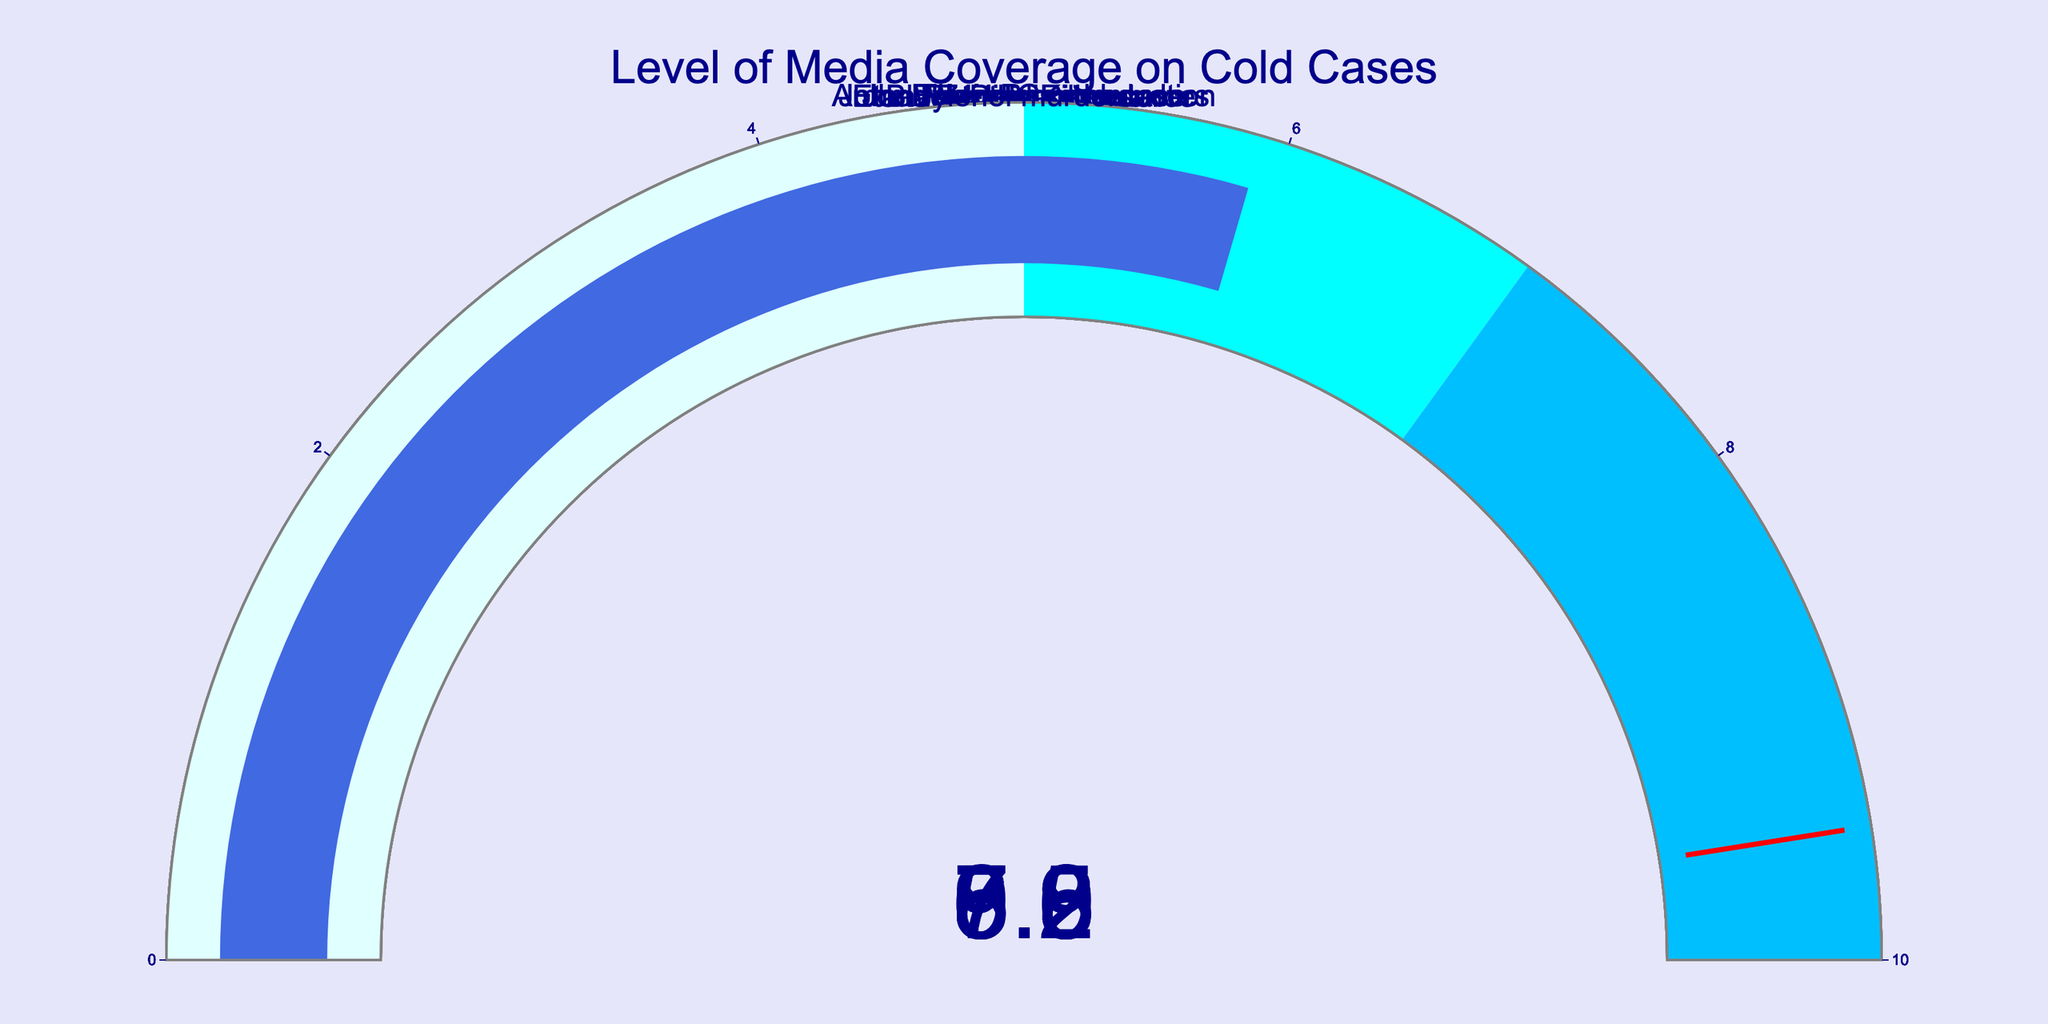What is the title of the figure? The title can be found at the top center of the figure and reads "Level of Media Coverage on Cold Cases."
Answer: Level of Media Coverage on Cold Cases What is the highest level of media coverage displayed in the figure? Look for the gauge chart with the highest numerical value. The JonBenét Ramsey case has a coverage level of 9.2.
Answer: 9.2 How many cold cases have a media coverage level above 7? Identify the gauge charts with values greater than 7. The John Wayne Gacy murders, JonBenét Ramsey case, Zodiac Killer, and Black Dahlia murder each have values above 7.
Answer: 4 Which cold case has the lowest level of media coverage? Look for the gauge chart with the smallest value. The Amber Hagerman abduction has the lowest media coverage level at 5.6.
Answer: Amber Hagerman abduction What is the average media coverage level of all the cold cases? Sum all the media coverage values and divide by the number of cases. (8.5 + 9.2 + 7.8 + 6.9 + 7.3 + 5.6 + 6.2 + 5.9) / 8 = 57.4 / 8 = 7.175
Answer: 7.175 Which cold case has a media coverage level closest to 6? Compare each value to see which is nearest to 6. The Etan Patz disappearance has a media coverage level of 6.2, which is the closest.
Answer: Etan Patz disappearance How many cases fall within the media coverage range of 5 to 7? Identify gauge charts that fall within the specified range. These include Amber Hagerman abduction (5.6), Etan Patz disappearance (6.2), and Tylenol murders (5.9).
Answer: 3 What is the median media coverage level of the cold cases? First, order the values: 5.6, 5.9, 6.2, 6.9, 7.3, 7.8, 8.5, 9.2. Since there are 8 values, the median will be the average of the 4th and 5th values: (6.9 + 7.3) / 2 = 7.1
Answer: 7.1 Which two cold cases have media coverage levels that are closest to each other? Evaluate the differences between each pair of values and find the closest. The Tylenol murders (5.9) and the Amber Hagerman abduction (5.6) have the smallest difference of 0.3.
Answer: Tylenol murders and Amber Hagerman abduction 